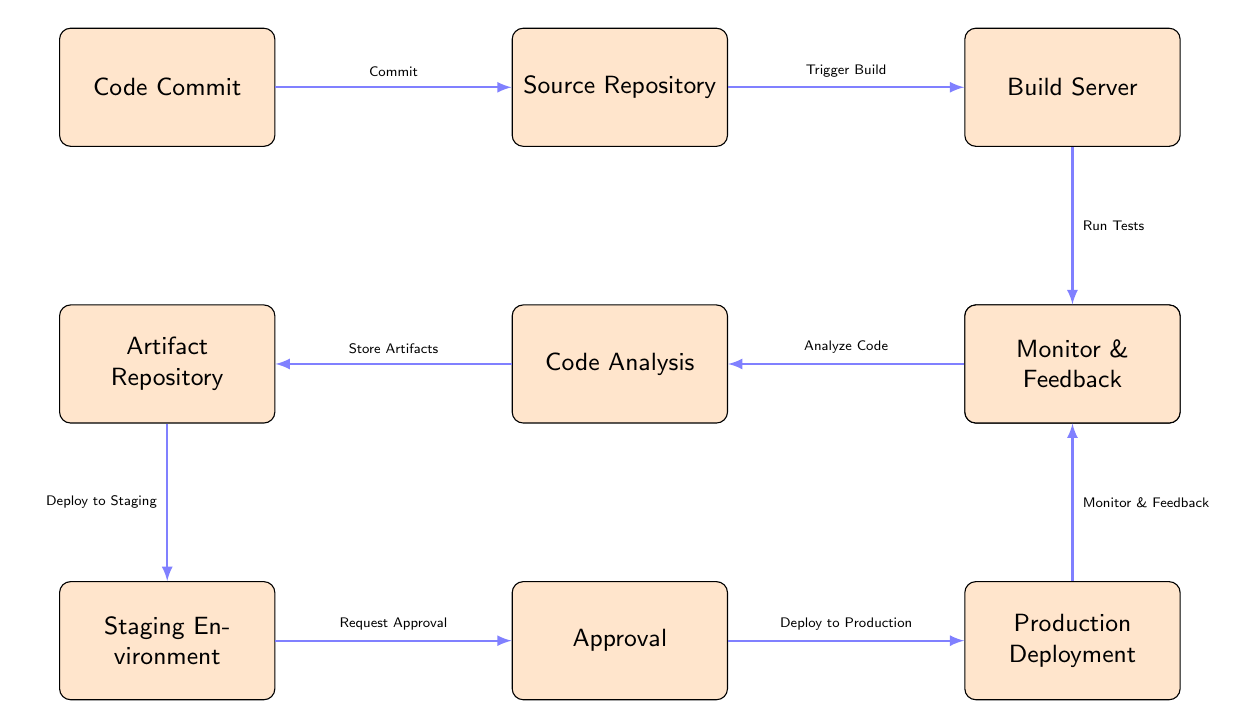What's the initial step in the process flow? The initial step in the process flow is represented by the first node, which is "Code Commit." This is where the process begins before moving to the next stages.
Answer: Code Commit How many nodes are there in the diagram? By counting all the distinct nodes displayed in the diagram, we find there are ten nodes in total, each representing different stages in the process flow.
Answer: 10 What is the relationship between the "Source Repository" and the "Build Server"? The diagram indicates a direct connection from "Source Repository" to "Build Server," with the action labeled "Trigger Build," signifying that once code is stored, it triggers the build process.
Answer: Trigger Build What is the last step before "Production Deployment"? The last step before "Production Deployment" is "Approval," which indicates that approval is required before any deployment to production occurs.
Answer: Approval Which stage is responsible for code quality assessment? The "Code Analysis" node in the diagram signifies the stage responsible for assessing the quality of the code after running tests. This indicates that analysis happens post-testing.
Answer: Code Analysis How does the process flow from "Staging Environment" to "Monitor & Feedback"? The flow from "Staging Environment" to "Monitor & Feedback" involves deploying to production first. After deployment, the monitoring and feedback processes occur, indicating a feedback loop after the production stage.
Answer: Deploy to Production What stage comes after "Automated Tests" in the flow? Following the "Automated Tests" node, the next stage is "Code Analysis," showing directly how tests lead to quality assessment in the development lifecycle.
Answer: Code Analysis Which process comes before "Deploy to Staging"? The process that occurs right before "Deploy to Staging" is "Store Artifacts," which indicates that artifacts must be stored before deploying them to a staging environment.
Answer: Store Artifacts What is the purpose of the "Monitor & Feedback" stage? The "Monitor & Feedback" stage serves the purpose of checking the performance and outcomes after deployment, ensuring continuous improvement based on real-world usage.
Answer: Performance monitoring 